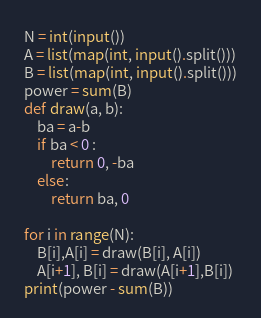<code> <loc_0><loc_0><loc_500><loc_500><_Python_>N = int(input())
A = list(map(int, input().split()))
B = list(map(int, input().split()))
power = sum(B)
def draw(a, b):
    ba = a-b
    if ba < 0 :
        return 0, -ba
    else:
        return ba, 0

for i in range(N):
    B[i],A[i] = draw(B[i], A[i])
    A[i+1], B[i] = draw(A[i+1],B[i])
print(power - sum(B))</code> 